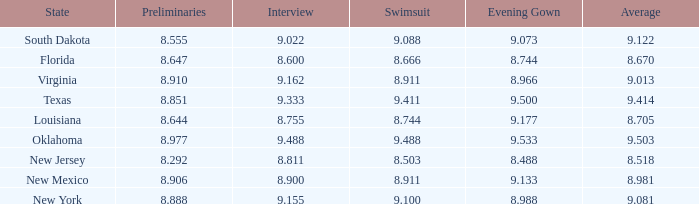What is the total number of average where evening gown is 8.988 1.0. 